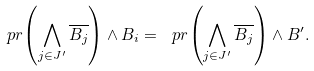<formula> <loc_0><loc_0><loc_500><loc_500>\ p r { \left ( \bigwedge _ { j \in J ^ { \prime } } \overline { B _ { j } } \right ) \wedge B _ { i } } = \ p r { \left ( \bigwedge _ { j \in J ^ { \prime } } \overline { B _ { j } } \right ) \wedge B ^ { \prime } } .</formula> 